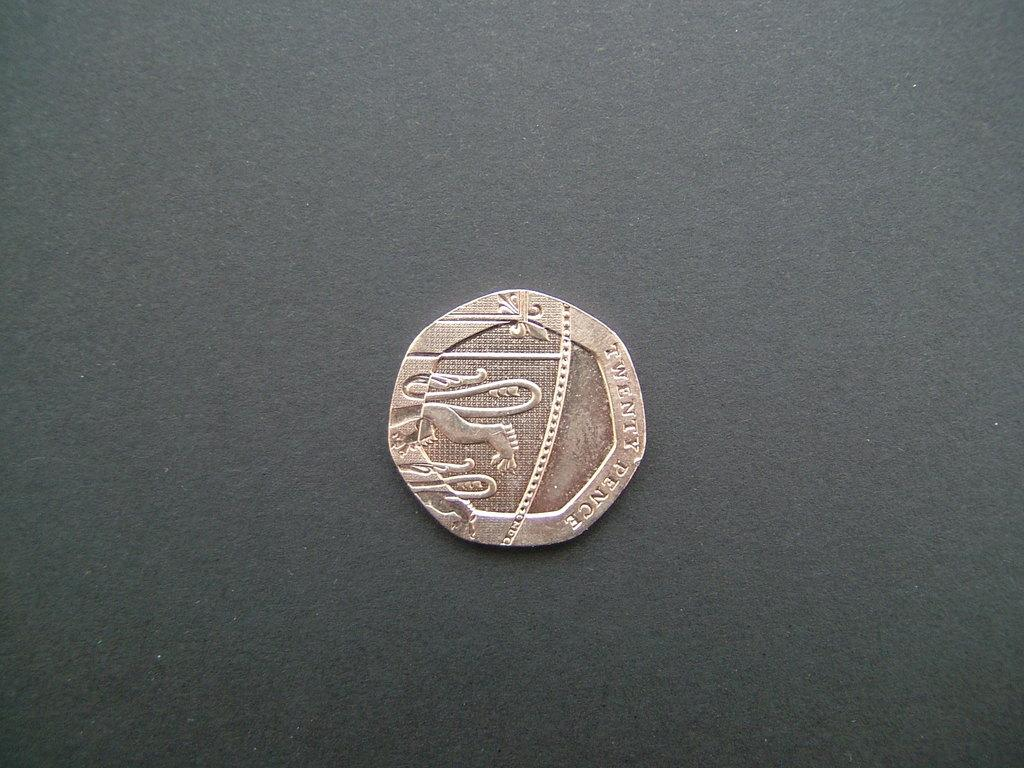<image>
Render a clear and concise summary of the photo. An old, wooden coin that is brownish in color sits on a black table. 